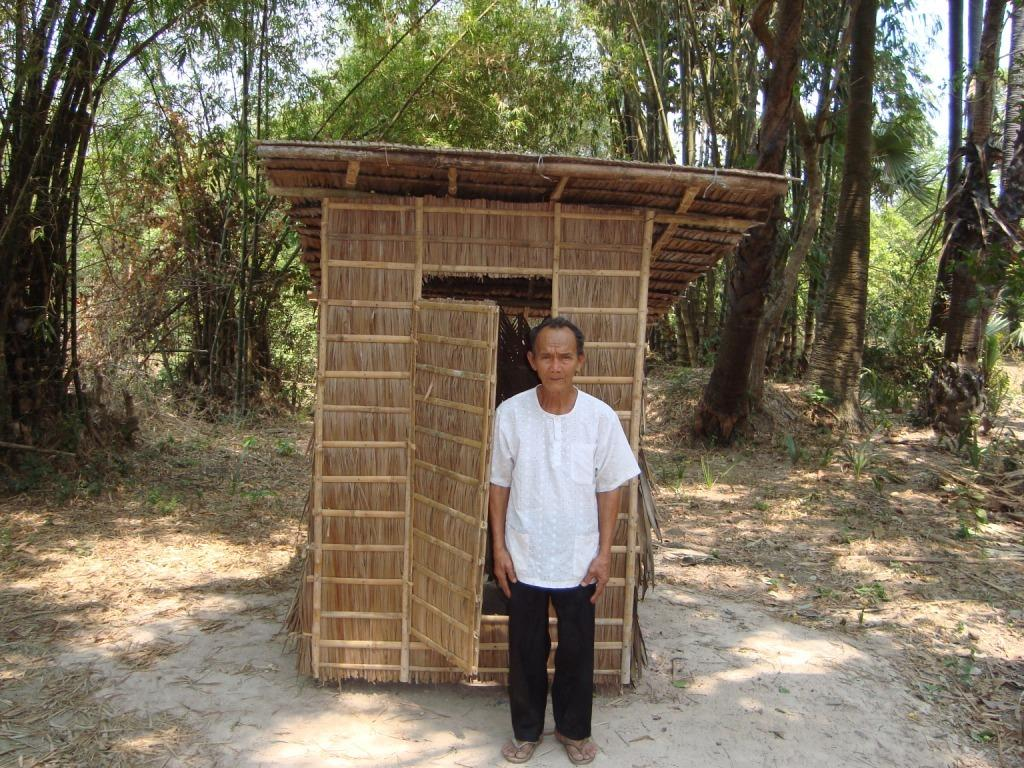What can be seen in the image? There is a person in the image. What is the person wearing? The person is wearing a white shirt and black pants. What is the person standing near? The person is standing near a wooden hurd. What can be seen in the background of the image? There are trees and the clear sky visible in the background of the image. What type of jam is the person spreading on the tray in the image? There is no tray or jam present in the image. What kind of paste is the person using to create the hurd in the image? The wooden hurd in the image is a pre-existing object and not created by the person in the image. 